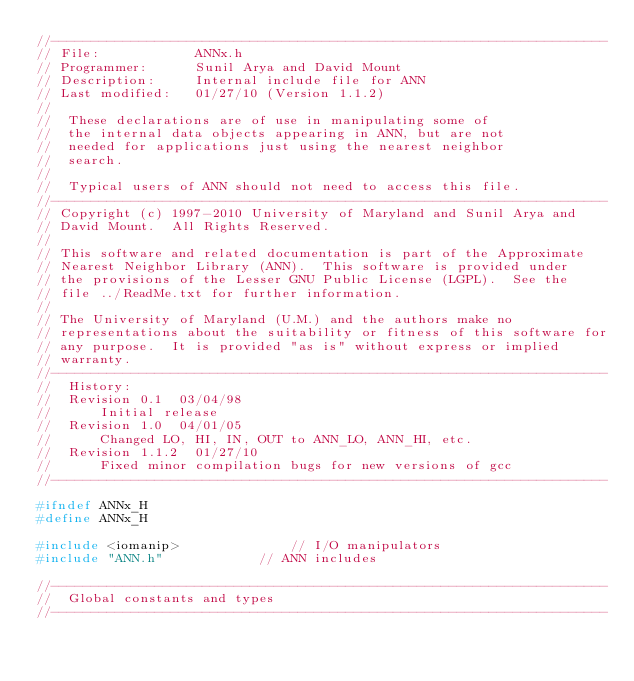Convert code to text. <code><loc_0><loc_0><loc_500><loc_500><_C_>//----------------------------------------------------------------------
// File:			ANNx.h
// Programmer: 		Sunil Arya and David Mount
// Description:		Internal include file for ANN
// Last modified:	01/27/10 (Version 1.1.2)
//
//	These declarations are of use in manipulating some of
//	the internal data objects appearing in ANN, but are not
//	needed for applications just using the nearest neighbor
//	search.
//
//	Typical users of ANN should not need to access this file.
//----------------------------------------------------------------------
// Copyright (c) 1997-2010 University of Maryland and Sunil Arya and
// David Mount.  All Rights Reserved.
// 
// This software and related documentation is part of the Approximate
// Nearest Neighbor Library (ANN).  This software is provided under
// the provisions of the Lesser GNU Public License (LGPL).  See the
// file ../ReadMe.txt for further information.
// 
// The University of Maryland (U.M.) and the authors make no
// representations about the suitability or fitness of this software for
// any purpose.  It is provided "as is" without express or implied
// warranty.
//----------------------------------------------------------------------
//	History:
//	Revision 0.1  03/04/98
//	    Initial release
//	Revision 1.0  04/01/05
//	    Changed LO, HI, IN, OUT to ANN_LO, ANN_HI, etc.
//	Revision 1.1.2  01/27/10
//		Fixed minor compilation bugs for new versions of gcc
//----------------------------------------------------------------------

#ifndef ANNx_H
#define ANNx_H

#include <iomanip>				// I/O manipulators
#include "ANN.h"			// ANN includes

//----------------------------------------------------------------------
//	Global constants and types
//----------------------------------------------------------------------</code> 